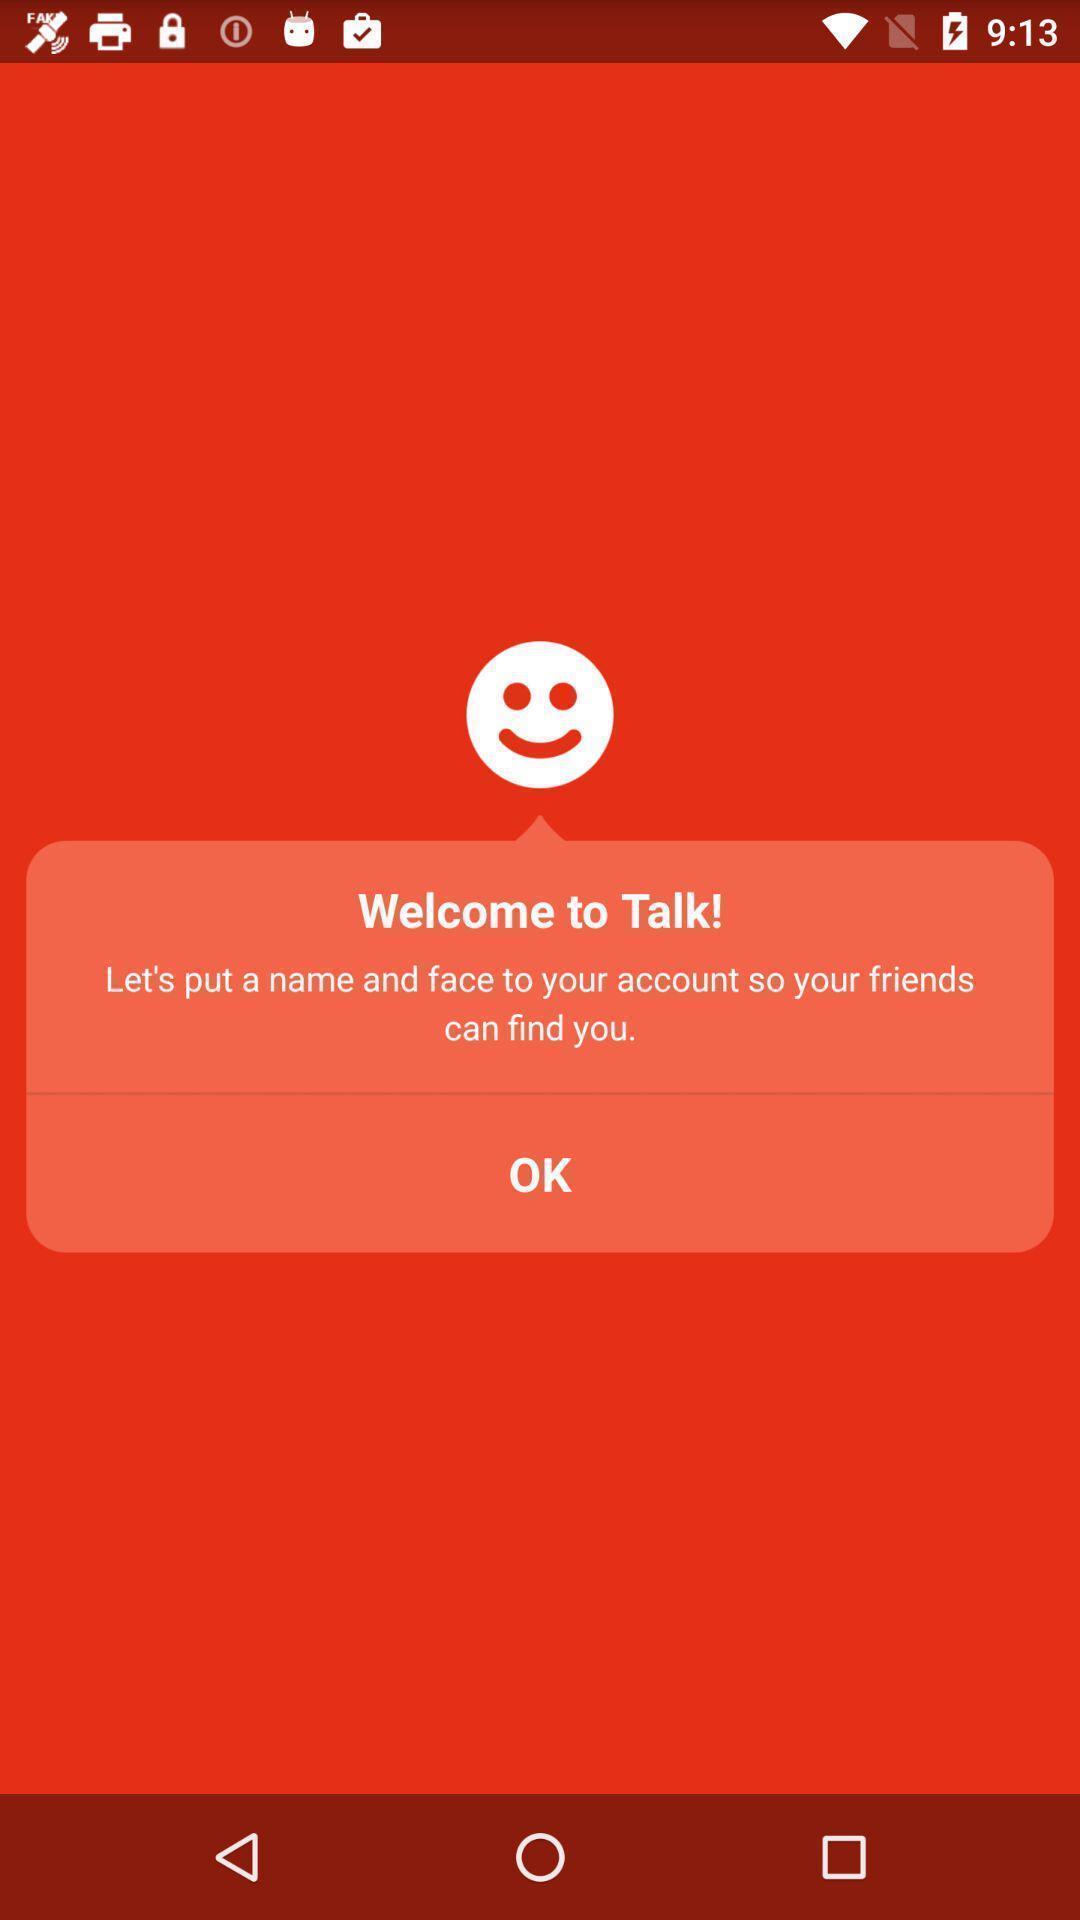Provide a textual representation of this image. Welcome page of the task. 